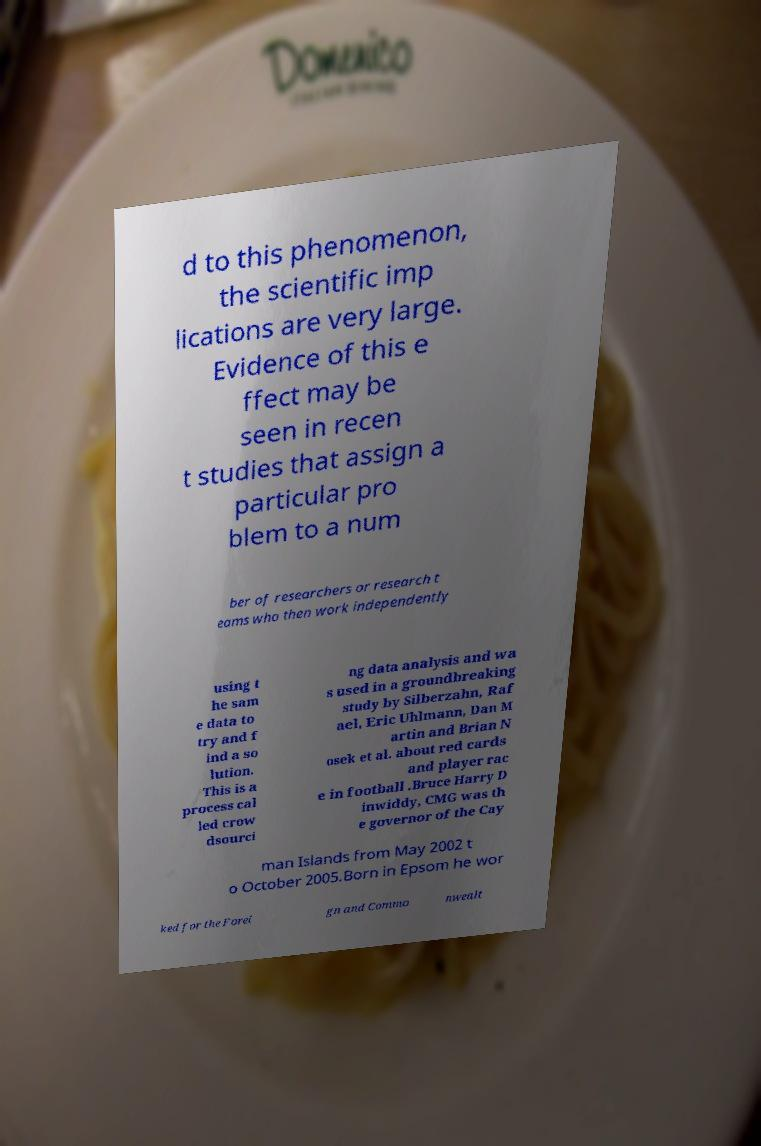There's text embedded in this image that I need extracted. Can you transcribe it verbatim? d to this phenomenon, the scientific imp lications are very large. Evidence of this e ffect may be seen in recen t studies that assign a particular pro blem to a num ber of researchers or research t eams who then work independently using t he sam e data to try and f ind a so lution. This is a process cal led crow dsourci ng data analysis and wa s used in a groundbreaking study by Silberzahn, Raf ael, Eric Uhlmann, Dan M artin and Brian N osek et al. about red cards and player rac e in football .Bruce Harry D inwiddy, CMG was th e governor of the Cay man Islands from May 2002 t o October 2005.Born in Epsom he wor ked for the Forei gn and Commo nwealt 